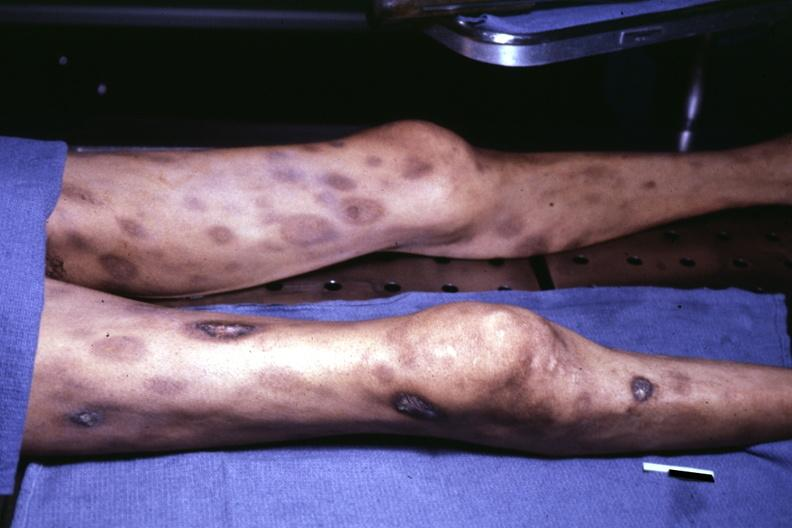how does view of thighs and legs at autopsy ecchymose?
Answer the question using a single word or phrase. With central necrosis 